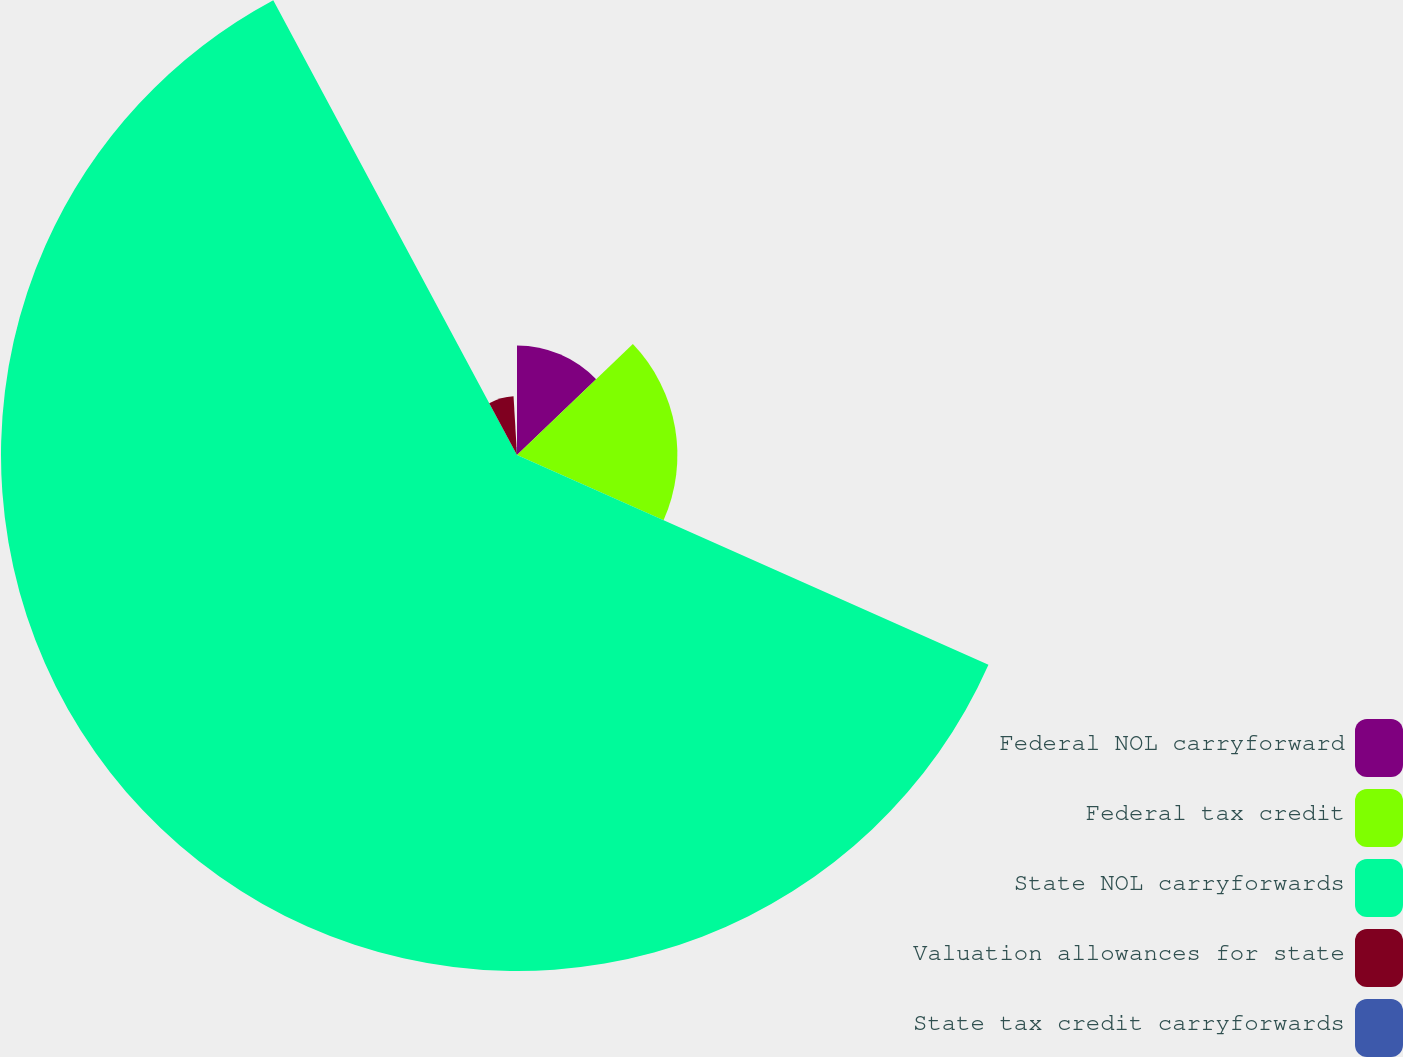Convert chart to OTSL. <chart><loc_0><loc_0><loc_500><loc_500><pie_chart><fcel>Federal NOL carryforward<fcel>Federal tax credit<fcel>State NOL carryforwards<fcel>Valuation allowances for state<fcel>State tax credit carryforwards<nl><fcel>12.85%<fcel>18.81%<fcel>60.51%<fcel>6.89%<fcel>0.94%<nl></chart> 